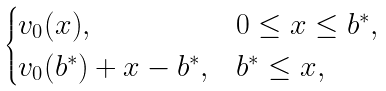Convert formula to latex. <formula><loc_0><loc_0><loc_500><loc_500>\begin{cases} v _ { 0 } ( x ) , & 0 \leq x \leq b ^ { * } , \\ v _ { 0 } ( b ^ { * } ) + x - b ^ { * } , & b ^ { * } \leq x , \end{cases}</formula> 